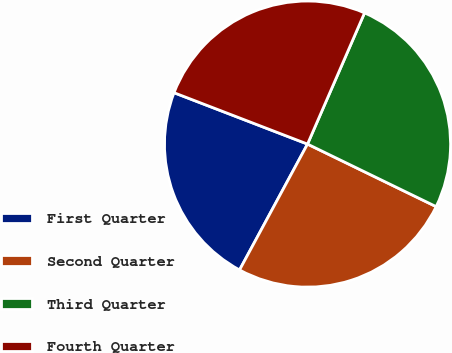<chart> <loc_0><loc_0><loc_500><loc_500><pie_chart><fcel>First Quarter<fcel>Second Quarter<fcel>Third Quarter<fcel>Fourth Quarter<nl><fcel>22.97%<fcel>25.68%<fcel>25.68%<fcel>25.68%<nl></chart> 